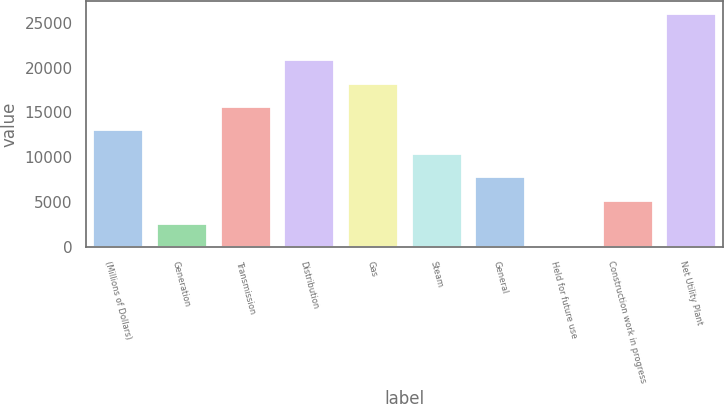<chart> <loc_0><loc_0><loc_500><loc_500><bar_chart><fcel>(Millions of Dollars)<fcel>Generation<fcel>Transmission<fcel>Distribution<fcel>Gas<fcel>Steam<fcel>General<fcel>Held for future use<fcel>Construction work in progress<fcel>Net Utility Plant<nl><fcel>13104<fcel>2670.4<fcel>15712.4<fcel>20929.2<fcel>18320.8<fcel>10495.6<fcel>7887.2<fcel>62<fcel>5278.8<fcel>26146<nl></chart> 